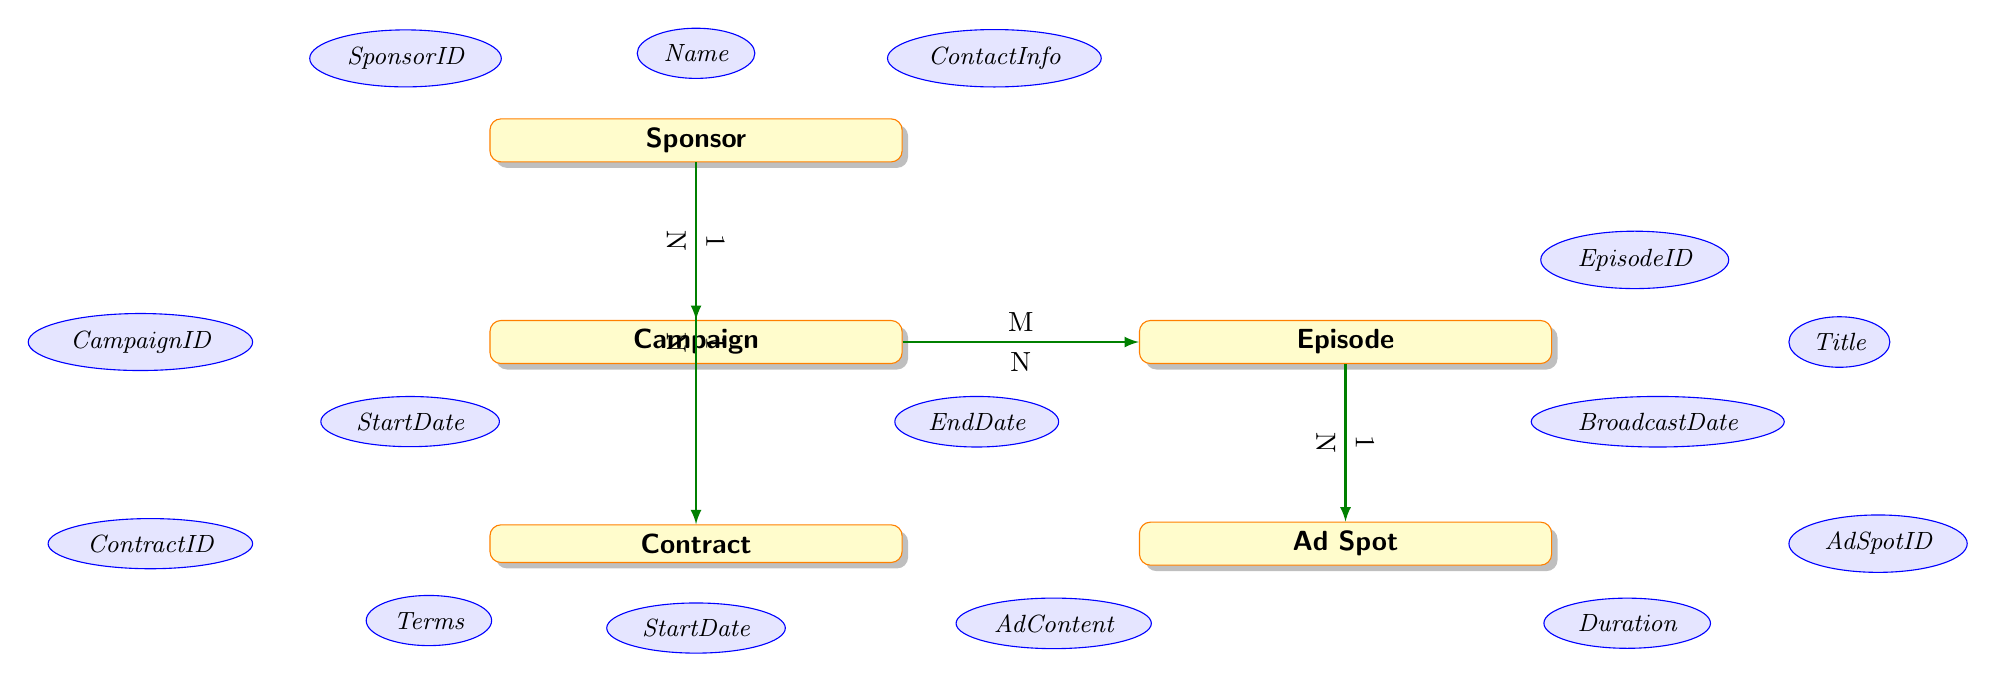What is the entity that represents advertisers in the diagram? The diagram clearly includes an entity labeled "Sponsor," which denotes the advertisers that run campaigns.
Answer: Sponsor How many attributes does the Campaign entity have? The Campaign entity has five attributes listed: CampaignID, SponsorID, Name, StartDate, and EndDate. Counting these, we find a total of five.
Answer: 5 What is the relationship between the Campaign and Episode entities? The relationship between the Campaign and Episode entities is marked as many-to-many, indicated by the notation M to N near the connecting arrow.
Answer: Many-toMany Which entity has a one-to-many relationship with the Ad Spot entity? The diagram shows that the Episode entity has a one-to-many relationship with the Ad Spot entity, as indicated by the arrows and the notation 1 to N.
Answer: Episode What guarantees participation of a Sponsor in a Contract? In the diagram, the Contract entity represents the terms of sponsorship that ensure the involvement of a Sponsor, evidenced by the arrow defining a one-to-many relationship from Sponsor to Contract.
Answer: Contract What attributes are associated with the Ad Spot entity? The Ad Spot entity includes three attributes listed: AdSpotID, AdContent, and Duration. These attributes are visually connected to the Ad Spot entity in the diagram.
Answer: AdSpotID, AdContent, Duration How does the Sponsor connect to the Campaign entity? The connection between Sponsor and Campaign is established through a many-to-one relationship, meaning one sponsor can run multiple campaigns, represented by the notation 1 to N on the diagram.
Answer: ManyToOne What type of relationship links Campaign and Episode? The Campaign and Episode entities are linked through a many-to-many relationship, as denoted by the M to N labeling on their connecting edge in the diagram.
Answer: ManyToMany Is there any direct relationship between Sponsor and Episode? There is no direct relationship drawn between the Sponsor and Episode entities in the diagram; the connection is indirect through the Campaign entity.
Answer: No 